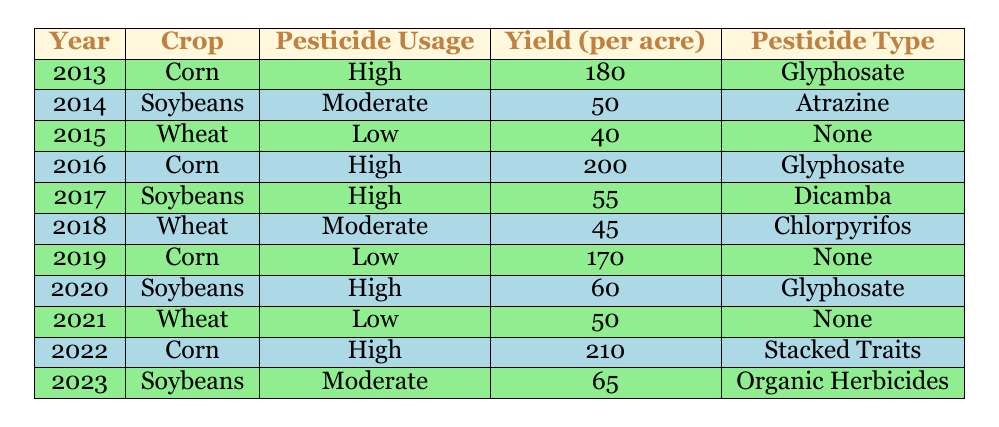What was the highest yield per acre for Corn in the table? The table shows yields for Corn in 2013 (180), 2016 (200), and 2022 (210). The highest yield among these is in 2022, which is 210.
Answer: 210 In which year did Soybeans have the highest pesticide usage, and what was the yield then? The highest pesticide usage for Soybeans occurred in 2020, with a yield of 60 per acre.
Answer: 2020, yield 60 How many years had Wheat with pesticide usage classified as Low, and what were the yields for those years? Wheat had Low pesticide usage in 2015 (yield 40) and 2021 (yield 50). Thus, there were two years.
Answer: 2 years, yields 40 and 50 What is the average yield for crops with High pesticide usage? The table indicates High usage yields are 180 (2013), 200 (2016), 55 (2017), 60 (2020), and 210 (2022). The sum is 180 + 200 + 55 + 60 + 210 = 705, and there are 5 data points. Therefore, the average is 705/5 = 141.
Answer: 141 Did any crop have a yield of more than 200 per acre while using pesticides? Yes, Corn in 2022 had a yield of 210 while using High pesticides.
Answer: Yes What is the difference in yield per acre for Soybeans from 2014 to 2023? The yield for Soybeans in 2014 was 50, and in 2023 it was 65, so the difference is 65 - 50 = 15.
Answer: 15 Was there any year when Corn had Low pesticide usage, and what was the yield then? Yes, in 2019, Corn had Low pesticide usage with a yield of 170 per acre.
Answer: Yes, yield 170 Which crop had the highest yield per acre with Moderate pesticide usage? The table lists Moderate usage yields for Soybeans (2014: 50, 2023: 65) and Wheat (2018: 45). The highest among these is Soybeans in 2023 with 65.
Answer: Soybeans in 2023, yield 65 In how many instances did Wheat have a yield greater than 45 with any pesticide usage? Wheat had yields of 40 (2015) and 50 (2021) with Low, and 45 (2018) with Moderate. Only 2018 (45) and 2021 (50) had yields above 45. Hence, there are two instances with yields greater than 45.
Answer: 1 instance, yield 50 